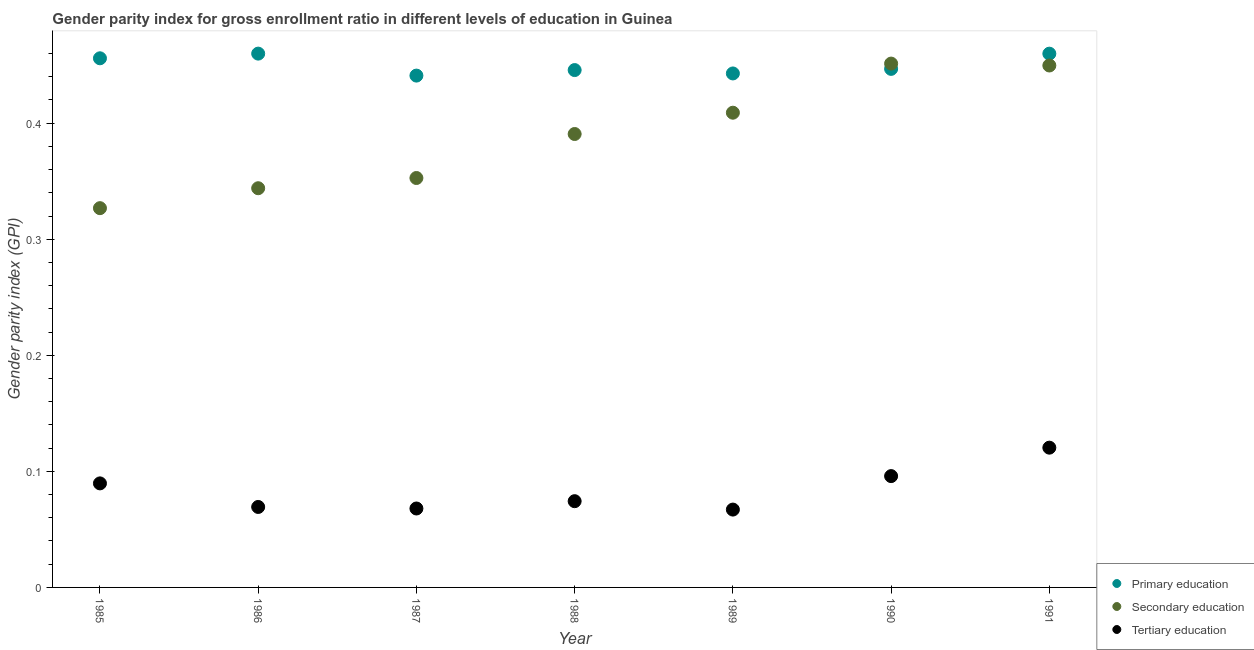How many different coloured dotlines are there?
Ensure brevity in your answer.  3. Is the number of dotlines equal to the number of legend labels?
Your answer should be compact. Yes. What is the gender parity index in tertiary education in 1991?
Your response must be concise. 0.12. Across all years, what is the maximum gender parity index in secondary education?
Your response must be concise. 0.45. Across all years, what is the minimum gender parity index in tertiary education?
Offer a very short reply. 0.07. In which year was the gender parity index in secondary education maximum?
Your response must be concise. 1990. In which year was the gender parity index in secondary education minimum?
Provide a short and direct response. 1985. What is the total gender parity index in secondary education in the graph?
Provide a succinct answer. 2.72. What is the difference between the gender parity index in primary education in 1986 and that in 1987?
Give a very brief answer. 0.02. What is the difference between the gender parity index in tertiary education in 1988 and the gender parity index in primary education in 1991?
Your answer should be compact. -0.39. What is the average gender parity index in secondary education per year?
Give a very brief answer. 0.39. In the year 1991, what is the difference between the gender parity index in secondary education and gender parity index in tertiary education?
Provide a short and direct response. 0.33. What is the ratio of the gender parity index in secondary education in 1985 to that in 1987?
Provide a succinct answer. 0.93. What is the difference between the highest and the second highest gender parity index in secondary education?
Your response must be concise. 0. What is the difference between the highest and the lowest gender parity index in secondary education?
Ensure brevity in your answer.  0.12. Is the sum of the gender parity index in secondary education in 1986 and 1987 greater than the maximum gender parity index in primary education across all years?
Your answer should be compact. Yes. Is it the case that in every year, the sum of the gender parity index in primary education and gender parity index in secondary education is greater than the gender parity index in tertiary education?
Provide a short and direct response. Yes. Does the gender parity index in tertiary education monotonically increase over the years?
Provide a succinct answer. No. Is the gender parity index in primary education strictly greater than the gender parity index in secondary education over the years?
Offer a terse response. No. How many dotlines are there?
Your response must be concise. 3. What is the title of the graph?
Your response must be concise. Gender parity index for gross enrollment ratio in different levels of education in Guinea. Does "Ores and metals" appear as one of the legend labels in the graph?
Keep it short and to the point. No. What is the label or title of the X-axis?
Ensure brevity in your answer.  Year. What is the label or title of the Y-axis?
Offer a very short reply. Gender parity index (GPI). What is the Gender parity index (GPI) in Primary education in 1985?
Give a very brief answer. 0.46. What is the Gender parity index (GPI) of Secondary education in 1985?
Your answer should be compact. 0.33. What is the Gender parity index (GPI) in Tertiary education in 1985?
Keep it short and to the point. 0.09. What is the Gender parity index (GPI) of Primary education in 1986?
Your answer should be compact. 0.46. What is the Gender parity index (GPI) of Secondary education in 1986?
Your answer should be very brief. 0.34. What is the Gender parity index (GPI) of Tertiary education in 1986?
Your answer should be compact. 0.07. What is the Gender parity index (GPI) of Primary education in 1987?
Offer a very short reply. 0.44. What is the Gender parity index (GPI) in Secondary education in 1987?
Offer a terse response. 0.35. What is the Gender parity index (GPI) in Tertiary education in 1987?
Provide a succinct answer. 0.07. What is the Gender parity index (GPI) of Primary education in 1988?
Your response must be concise. 0.45. What is the Gender parity index (GPI) in Secondary education in 1988?
Ensure brevity in your answer.  0.39. What is the Gender parity index (GPI) in Tertiary education in 1988?
Your answer should be very brief. 0.07. What is the Gender parity index (GPI) of Primary education in 1989?
Provide a short and direct response. 0.44. What is the Gender parity index (GPI) of Secondary education in 1989?
Ensure brevity in your answer.  0.41. What is the Gender parity index (GPI) of Tertiary education in 1989?
Ensure brevity in your answer.  0.07. What is the Gender parity index (GPI) of Primary education in 1990?
Your answer should be very brief. 0.45. What is the Gender parity index (GPI) of Secondary education in 1990?
Offer a very short reply. 0.45. What is the Gender parity index (GPI) of Tertiary education in 1990?
Provide a succinct answer. 0.1. What is the Gender parity index (GPI) in Primary education in 1991?
Offer a terse response. 0.46. What is the Gender parity index (GPI) of Secondary education in 1991?
Your response must be concise. 0.45. What is the Gender parity index (GPI) of Tertiary education in 1991?
Offer a very short reply. 0.12. Across all years, what is the maximum Gender parity index (GPI) in Primary education?
Provide a short and direct response. 0.46. Across all years, what is the maximum Gender parity index (GPI) of Secondary education?
Give a very brief answer. 0.45. Across all years, what is the maximum Gender parity index (GPI) in Tertiary education?
Provide a short and direct response. 0.12. Across all years, what is the minimum Gender parity index (GPI) in Primary education?
Offer a very short reply. 0.44. Across all years, what is the minimum Gender parity index (GPI) in Secondary education?
Your answer should be very brief. 0.33. Across all years, what is the minimum Gender parity index (GPI) in Tertiary education?
Give a very brief answer. 0.07. What is the total Gender parity index (GPI) of Primary education in the graph?
Ensure brevity in your answer.  3.15. What is the total Gender parity index (GPI) of Secondary education in the graph?
Offer a terse response. 2.72. What is the total Gender parity index (GPI) in Tertiary education in the graph?
Ensure brevity in your answer.  0.58. What is the difference between the Gender parity index (GPI) of Primary education in 1985 and that in 1986?
Your response must be concise. -0. What is the difference between the Gender parity index (GPI) of Secondary education in 1985 and that in 1986?
Provide a short and direct response. -0.02. What is the difference between the Gender parity index (GPI) of Tertiary education in 1985 and that in 1986?
Keep it short and to the point. 0.02. What is the difference between the Gender parity index (GPI) in Primary education in 1985 and that in 1987?
Offer a very short reply. 0.01. What is the difference between the Gender parity index (GPI) in Secondary education in 1985 and that in 1987?
Provide a short and direct response. -0.03. What is the difference between the Gender parity index (GPI) of Tertiary education in 1985 and that in 1987?
Offer a very short reply. 0.02. What is the difference between the Gender parity index (GPI) of Primary education in 1985 and that in 1988?
Keep it short and to the point. 0.01. What is the difference between the Gender parity index (GPI) of Secondary education in 1985 and that in 1988?
Give a very brief answer. -0.06. What is the difference between the Gender parity index (GPI) in Tertiary education in 1985 and that in 1988?
Provide a succinct answer. 0.02. What is the difference between the Gender parity index (GPI) of Primary education in 1985 and that in 1989?
Your answer should be compact. 0.01. What is the difference between the Gender parity index (GPI) of Secondary education in 1985 and that in 1989?
Keep it short and to the point. -0.08. What is the difference between the Gender parity index (GPI) of Tertiary education in 1985 and that in 1989?
Your answer should be compact. 0.02. What is the difference between the Gender parity index (GPI) in Primary education in 1985 and that in 1990?
Your answer should be compact. 0.01. What is the difference between the Gender parity index (GPI) of Secondary education in 1985 and that in 1990?
Your answer should be very brief. -0.12. What is the difference between the Gender parity index (GPI) in Tertiary education in 1985 and that in 1990?
Offer a very short reply. -0.01. What is the difference between the Gender parity index (GPI) in Primary education in 1985 and that in 1991?
Offer a very short reply. -0. What is the difference between the Gender parity index (GPI) of Secondary education in 1985 and that in 1991?
Your response must be concise. -0.12. What is the difference between the Gender parity index (GPI) of Tertiary education in 1985 and that in 1991?
Give a very brief answer. -0.03. What is the difference between the Gender parity index (GPI) of Primary education in 1986 and that in 1987?
Your response must be concise. 0.02. What is the difference between the Gender parity index (GPI) in Secondary education in 1986 and that in 1987?
Keep it short and to the point. -0.01. What is the difference between the Gender parity index (GPI) of Tertiary education in 1986 and that in 1987?
Your response must be concise. 0. What is the difference between the Gender parity index (GPI) of Primary education in 1986 and that in 1988?
Make the answer very short. 0.01. What is the difference between the Gender parity index (GPI) of Secondary education in 1986 and that in 1988?
Offer a terse response. -0.05. What is the difference between the Gender parity index (GPI) in Tertiary education in 1986 and that in 1988?
Keep it short and to the point. -0.01. What is the difference between the Gender parity index (GPI) of Primary education in 1986 and that in 1989?
Your answer should be compact. 0.02. What is the difference between the Gender parity index (GPI) in Secondary education in 1986 and that in 1989?
Offer a very short reply. -0.07. What is the difference between the Gender parity index (GPI) in Tertiary education in 1986 and that in 1989?
Give a very brief answer. 0. What is the difference between the Gender parity index (GPI) in Primary education in 1986 and that in 1990?
Give a very brief answer. 0.01. What is the difference between the Gender parity index (GPI) of Secondary education in 1986 and that in 1990?
Ensure brevity in your answer.  -0.11. What is the difference between the Gender parity index (GPI) of Tertiary education in 1986 and that in 1990?
Give a very brief answer. -0.03. What is the difference between the Gender parity index (GPI) in Primary education in 1986 and that in 1991?
Your answer should be compact. 0. What is the difference between the Gender parity index (GPI) in Secondary education in 1986 and that in 1991?
Offer a terse response. -0.11. What is the difference between the Gender parity index (GPI) in Tertiary education in 1986 and that in 1991?
Make the answer very short. -0.05. What is the difference between the Gender parity index (GPI) in Primary education in 1987 and that in 1988?
Offer a terse response. -0. What is the difference between the Gender parity index (GPI) of Secondary education in 1987 and that in 1988?
Provide a succinct answer. -0.04. What is the difference between the Gender parity index (GPI) in Tertiary education in 1987 and that in 1988?
Offer a very short reply. -0.01. What is the difference between the Gender parity index (GPI) of Primary education in 1987 and that in 1989?
Provide a short and direct response. -0. What is the difference between the Gender parity index (GPI) in Secondary education in 1987 and that in 1989?
Provide a succinct answer. -0.06. What is the difference between the Gender parity index (GPI) of Tertiary education in 1987 and that in 1989?
Your answer should be very brief. 0. What is the difference between the Gender parity index (GPI) of Primary education in 1987 and that in 1990?
Give a very brief answer. -0.01. What is the difference between the Gender parity index (GPI) of Secondary education in 1987 and that in 1990?
Make the answer very short. -0.1. What is the difference between the Gender parity index (GPI) in Tertiary education in 1987 and that in 1990?
Your answer should be compact. -0.03. What is the difference between the Gender parity index (GPI) in Primary education in 1987 and that in 1991?
Make the answer very short. -0.02. What is the difference between the Gender parity index (GPI) of Secondary education in 1987 and that in 1991?
Your answer should be very brief. -0.1. What is the difference between the Gender parity index (GPI) of Tertiary education in 1987 and that in 1991?
Keep it short and to the point. -0.05. What is the difference between the Gender parity index (GPI) of Primary education in 1988 and that in 1989?
Give a very brief answer. 0. What is the difference between the Gender parity index (GPI) in Secondary education in 1988 and that in 1989?
Make the answer very short. -0.02. What is the difference between the Gender parity index (GPI) in Tertiary education in 1988 and that in 1989?
Ensure brevity in your answer.  0.01. What is the difference between the Gender parity index (GPI) of Primary education in 1988 and that in 1990?
Offer a terse response. -0. What is the difference between the Gender parity index (GPI) in Secondary education in 1988 and that in 1990?
Offer a very short reply. -0.06. What is the difference between the Gender parity index (GPI) in Tertiary education in 1988 and that in 1990?
Give a very brief answer. -0.02. What is the difference between the Gender parity index (GPI) in Primary education in 1988 and that in 1991?
Your response must be concise. -0.01. What is the difference between the Gender parity index (GPI) of Secondary education in 1988 and that in 1991?
Provide a short and direct response. -0.06. What is the difference between the Gender parity index (GPI) in Tertiary education in 1988 and that in 1991?
Offer a very short reply. -0.05. What is the difference between the Gender parity index (GPI) in Primary education in 1989 and that in 1990?
Your answer should be compact. -0. What is the difference between the Gender parity index (GPI) of Secondary education in 1989 and that in 1990?
Ensure brevity in your answer.  -0.04. What is the difference between the Gender parity index (GPI) in Tertiary education in 1989 and that in 1990?
Ensure brevity in your answer.  -0.03. What is the difference between the Gender parity index (GPI) of Primary education in 1989 and that in 1991?
Keep it short and to the point. -0.02. What is the difference between the Gender parity index (GPI) of Secondary education in 1989 and that in 1991?
Offer a very short reply. -0.04. What is the difference between the Gender parity index (GPI) of Tertiary education in 1989 and that in 1991?
Keep it short and to the point. -0.05. What is the difference between the Gender parity index (GPI) in Primary education in 1990 and that in 1991?
Make the answer very short. -0.01. What is the difference between the Gender parity index (GPI) in Secondary education in 1990 and that in 1991?
Your answer should be very brief. 0. What is the difference between the Gender parity index (GPI) in Tertiary education in 1990 and that in 1991?
Ensure brevity in your answer.  -0.02. What is the difference between the Gender parity index (GPI) in Primary education in 1985 and the Gender parity index (GPI) in Secondary education in 1986?
Provide a succinct answer. 0.11. What is the difference between the Gender parity index (GPI) in Primary education in 1985 and the Gender parity index (GPI) in Tertiary education in 1986?
Your response must be concise. 0.39. What is the difference between the Gender parity index (GPI) of Secondary education in 1985 and the Gender parity index (GPI) of Tertiary education in 1986?
Provide a succinct answer. 0.26. What is the difference between the Gender parity index (GPI) in Primary education in 1985 and the Gender parity index (GPI) in Secondary education in 1987?
Provide a succinct answer. 0.1. What is the difference between the Gender parity index (GPI) of Primary education in 1985 and the Gender parity index (GPI) of Tertiary education in 1987?
Offer a terse response. 0.39. What is the difference between the Gender parity index (GPI) of Secondary education in 1985 and the Gender parity index (GPI) of Tertiary education in 1987?
Offer a very short reply. 0.26. What is the difference between the Gender parity index (GPI) of Primary education in 1985 and the Gender parity index (GPI) of Secondary education in 1988?
Provide a succinct answer. 0.07. What is the difference between the Gender parity index (GPI) in Primary education in 1985 and the Gender parity index (GPI) in Tertiary education in 1988?
Keep it short and to the point. 0.38. What is the difference between the Gender parity index (GPI) of Secondary education in 1985 and the Gender parity index (GPI) of Tertiary education in 1988?
Offer a very short reply. 0.25. What is the difference between the Gender parity index (GPI) in Primary education in 1985 and the Gender parity index (GPI) in Secondary education in 1989?
Provide a succinct answer. 0.05. What is the difference between the Gender parity index (GPI) of Primary education in 1985 and the Gender parity index (GPI) of Tertiary education in 1989?
Your response must be concise. 0.39. What is the difference between the Gender parity index (GPI) of Secondary education in 1985 and the Gender parity index (GPI) of Tertiary education in 1989?
Offer a very short reply. 0.26. What is the difference between the Gender parity index (GPI) of Primary education in 1985 and the Gender parity index (GPI) of Secondary education in 1990?
Offer a very short reply. 0. What is the difference between the Gender parity index (GPI) of Primary education in 1985 and the Gender parity index (GPI) of Tertiary education in 1990?
Offer a very short reply. 0.36. What is the difference between the Gender parity index (GPI) in Secondary education in 1985 and the Gender parity index (GPI) in Tertiary education in 1990?
Your answer should be very brief. 0.23. What is the difference between the Gender parity index (GPI) in Primary education in 1985 and the Gender parity index (GPI) in Secondary education in 1991?
Your response must be concise. 0.01. What is the difference between the Gender parity index (GPI) of Primary education in 1985 and the Gender parity index (GPI) of Tertiary education in 1991?
Make the answer very short. 0.34. What is the difference between the Gender parity index (GPI) of Secondary education in 1985 and the Gender parity index (GPI) of Tertiary education in 1991?
Provide a succinct answer. 0.21. What is the difference between the Gender parity index (GPI) in Primary education in 1986 and the Gender parity index (GPI) in Secondary education in 1987?
Offer a very short reply. 0.11. What is the difference between the Gender parity index (GPI) in Primary education in 1986 and the Gender parity index (GPI) in Tertiary education in 1987?
Offer a very short reply. 0.39. What is the difference between the Gender parity index (GPI) in Secondary education in 1986 and the Gender parity index (GPI) in Tertiary education in 1987?
Your answer should be very brief. 0.28. What is the difference between the Gender parity index (GPI) in Primary education in 1986 and the Gender parity index (GPI) in Secondary education in 1988?
Your answer should be very brief. 0.07. What is the difference between the Gender parity index (GPI) in Primary education in 1986 and the Gender parity index (GPI) in Tertiary education in 1988?
Provide a succinct answer. 0.39. What is the difference between the Gender parity index (GPI) of Secondary education in 1986 and the Gender parity index (GPI) of Tertiary education in 1988?
Keep it short and to the point. 0.27. What is the difference between the Gender parity index (GPI) of Primary education in 1986 and the Gender parity index (GPI) of Secondary education in 1989?
Offer a very short reply. 0.05. What is the difference between the Gender parity index (GPI) of Primary education in 1986 and the Gender parity index (GPI) of Tertiary education in 1989?
Your response must be concise. 0.39. What is the difference between the Gender parity index (GPI) in Secondary education in 1986 and the Gender parity index (GPI) in Tertiary education in 1989?
Make the answer very short. 0.28. What is the difference between the Gender parity index (GPI) in Primary education in 1986 and the Gender parity index (GPI) in Secondary education in 1990?
Offer a terse response. 0.01. What is the difference between the Gender parity index (GPI) in Primary education in 1986 and the Gender parity index (GPI) in Tertiary education in 1990?
Offer a terse response. 0.36. What is the difference between the Gender parity index (GPI) of Secondary education in 1986 and the Gender parity index (GPI) of Tertiary education in 1990?
Ensure brevity in your answer.  0.25. What is the difference between the Gender parity index (GPI) in Primary education in 1986 and the Gender parity index (GPI) in Secondary education in 1991?
Make the answer very short. 0.01. What is the difference between the Gender parity index (GPI) in Primary education in 1986 and the Gender parity index (GPI) in Tertiary education in 1991?
Your answer should be very brief. 0.34. What is the difference between the Gender parity index (GPI) in Secondary education in 1986 and the Gender parity index (GPI) in Tertiary education in 1991?
Keep it short and to the point. 0.22. What is the difference between the Gender parity index (GPI) of Primary education in 1987 and the Gender parity index (GPI) of Secondary education in 1988?
Your answer should be compact. 0.05. What is the difference between the Gender parity index (GPI) in Primary education in 1987 and the Gender parity index (GPI) in Tertiary education in 1988?
Your answer should be compact. 0.37. What is the difference between the Gender parity index (GPI) of Secondary education in 1987 and the Gender parity index (GPI) of Tertiary education in 1988?
Make the answer very short. 0.28. What is the difference between the Gender parity index (GPI) in Primary education in 1987 and the Gender parity index (GPI) in Secondary education in 1989?
Make the answer very short. 0.03. What is the difference between the Gender parity index (GPI) in Primary education in 1987 and the Gender parity index (GPI) in Tertiary education in 1989?
Keep it short and to the point. 0.37. What is the difference between the Gender parity index (GPI) of Secondary education in 1987 and the Gender parity index (GPI) of Tertiary education in 1989?
Your answer should be very brief. 0.29. What is the difference between the Gender parity index (GPI) of Primary education in 1987 and the Gender parity index (GPI) of Secondary education in 1990?
Offer a very short reply. -0.01. What is the difference between the Gender parity index (GPI) of Primary education in 1987 and the Gender parity index (GPI) of Tertiary education in 1990?
Provide a succinct answer. 0.35. What is the difference between the Gender parity index (GPI) in Secondary education in 1987 and the Gender parity index (GPI) in Tertiary education in 1990?
Provide a short and direct response. 0.26. What is the difference between the Gender parity index (GPI) of Primary education in 1987 and the Gender parity index (GPI) of Secondary education in 1991?
Provide a succinct answer. -0.01. What is the difference between the Gender parity index (GPI) in Primary education in 1987 and the Gender parity index (GPI) in Tertiary education in 1991?
Your answer should be compact. 0.32. What is the difference between the Gender parity index (GPI) in Secondary education in 1987 and the Gender parity index (GPI) in Tertiary education in 1991?
Give a very brief answer. 0.23. What is the difference between the Gender parity index (GPI) of Primary education in 1988 and the Gender parity index (GPI) of Secondary education in 1989?
Make the answer very short. 0.04. What is the difference between the Gender parity index (GPI) in Primary education in 1988 and the Gender parity index (GPI) in Tertiary education in 1989?
Your answer should be very brief. 0.38. What is the difference between the Gender parity index (GPI) in Secondary education in 1988 and the Gender parity index (GPI) in Tertiary education in 1989?
Make the answer very short. 0.32. What is the difference between the Gender parity index (GPI) of Primary education in 1988 and the Gender parity index (GPI) of Secondary education in 1990?
Your answer should be very brief. -0.01. What is the difference between the Gender parity index (GPI) of Primary education in 1988 and the Gender parity index (GPI) of Tertiary education in 1990?
Provide a succinct answer. 0.35. What is the difference between the Gender parity index (GPI) in Secondary education in 1988 and the Gender parity index (GPI) in Tertiary education in 1990?
Provide a succinct answer. 0.29. What is the difference between the Gender parity index (GPI) in Primary education in 1988 and the Gender parity index (GPI) in Secondary education in 1991?
Your response must be concise. -0. What is the difference between the Gender parity index (GPI) of Primary education in 1988 and the Gender parity index (GPI) of Tertiary education in 1991?
Make the answer very short. 0.33. What is the difference between the Gender parity index (GPI) in Secondary education in 1988 and the Gender parity index (GPI) in Tertiary education in 1991?
Your answer should be compact. 0.27. What is the difference between the Gender parity index (GPI) of Primary education in 1989 and the Gender parity index (GPI) of Secondary education in 1990?
Offer a terse response. -0.01. What is the difference between the Gender parity index (GPI) of Primary education in 1989 and the Gender parity index (GPI) of Tertiary education in 1990?
Provide a short and direct response. 0.35. What is the difference between the Gender parity index (GPI) in Secondary education in 1989 and the Gender parity index (GPI) in Tertiary education in 1990?
Keep it short and to the point. 0.31. What is the difference between the Gender parity index (GPI) of Primary education in 1989 and the Gender parity index (GPI) of Secondary education in 1991?
Offer a terse response. -0.01. What is the difference between the Gender parity index (GPI) in Primary education in 1989 and the Gender parity index (GPI) in Tertiary education in 1991?
Offer a very short reply. 0.32. What is the difference between the Gender parity index (GPI) of Secondary education in 1989 and the Gender parity index (GPI) of Tertiary education in 1991?
Give a very brief answer. 0.29. What is the difference between the Gender parity index (GPI) of Primary education in 1990 and the Gender parity index (GPI) of Secondary education in 1991?
Offer a very short reply. -0. What is the difference between the Gender parity index (GPI) in Primary education in 1990 and the Gender parity index (GPI) in Tertiary education in 1991?
Your answer should be compact. 0.33. What is the difference between the Gender parity index (GPI) of Secondary education in 1990 and the Gender parity index (GPI) of Tertiary education in 1991?
Make the answer very short. 0.33. What is the average Gender parity index (GPI) in Primary education per year?
Make the answer very short. 0.45. What is the average Gender parity index (GPI) of Secondary education per year?
Your answer should be very brief. 0.39. What is the average Gender parity index (GPI) in Tertiary education per year?
Offer a terse response. 0.08. In the year 1985, what is the difference between the Gender parity index (GPI) in Primary education and Gender parity index (GPI) in Secondary education?
Provide a succinct answer. 0.13. In the year 1985, what is the difference between the Gender parity index (GPI) in Primary education and Gender parity index (GPI) in Tertiary education?
Keep it short and to the point. 0.37. In the year 1985, what is the difference between the Gender parity index (GPI) of Secondary education and Gender parity index (GPI) of Tertiary education?
Provide a succinct answer. 0.24. In the year 1986, what is the difference between the Gender parity index (GPI) of Primary education and Gender parity index (GPI) of Secondary education?
Make the answer very short. 0.12. In the year 1986, what is the difference between the Gender parity index (GPI) in Primary education and Gender parity index (GPI) in Tertiary education?
Offer a very short reply. 0.39. In the year 1986, what is the difference between the Gender parity index (GPI) of Secondary education and Gender parity index (GPI) of Tertiary education?
Keep it short and to the point. 0.27. In the year 1987, what is the difference between the Gender parity index (GPI) of Primary education and Gender parity index (GPI) of Secondary education?
Your response must be concise. 0.09. In the year 1987, what is the difference between the Gender parity index (GPI) of Primary education and Gender parity index (GPI) of Tertiary education?
Keep it short and to the point. 0.37. In the year 1987, what is the difference between the Gender parity index (GPI) of Secondary education and Gender parity index (GPI) of Tertiary education?
Your answer should be compact. 0.28. In the year 1988, what is the difference between the Gender parity index (GPI) of Primary education and Gender parity index (GPI) of Secondary education?
Provide a short and direct response. 0.06. In the year 1988, what is the difference between the Gender parity index (GPI) of Primary education and Gender parity index (GPI) of Tertiary education?
Your response must be concise. 0.37. In the year 1988, what is the difference between the Gender parity index (GPI) in Secondary education and Gender parity index (GPI) in Tertiary education?
Keep it short and to the point. 0.32. In the year 1989, what is the difference between the Gender parity index (GPI) in Primary education and Gender parity index (GPI) in Secondary education?
Make the answer very short. 0.03. In the year 1989, what is the difference between the Gender parity index (GPI) in Primary education and Gender parity index (GPI) in Tertiary education?
Ensure brevity in your answer.  0.38. In the year 1989, what is the difference between the Gender parity index (GPI) of Secondary education and Gender parity index (GPI) of Tertiary education?
Give a very brief answer. 0.34. In the year 1990, what is the difference between the Gender parity index (GPI) of Primary education and Gender parity index (GPI) of Secondary education?
Give a very brief answer. -0. In the year 1990, what is the difference between the Gender parity index (GPI) in Primary education and Gender parity index (GPI) in Tertiary education?
Provide a succinct answer. 0.35. In the year 1990, what is the difference between the Gender parity index (GPI) of Secondary education and Gender parity index (GPI) of Tertiary education?
Your answer should be very brief. 0.36. In the year 1991, what is the difference between the Gender parity index (GPI) in Primary education and Gender parity index (GPI) in Secondary education?
Provide a short and direct response. 0.01. In the year 1991, what is the difference between the Gender parity index (GPI) in Primary education and Gender parity index (GPI) in Tertiary education?
Offer a very short reply. 0.34. In the year 1991, what is the difference between the Gender parity index (GPI) of Secondary education and Gender parity index (GPI) of Tertiary education?
Make the answer very short. 0.33. What is the ratio of the Gender parity index (GPI) in Primary education in 1985 to that in 1986?
Your answer should be compact. 0.99. What is the ratio of the Gender parity index (GPI) of Secondary education in 1985 to that in 1986?
Your answer should be very brief. 0.95. What is the ratio of the Gender parity index (GPI) of Tertiary education in 1985 to that in 1986?
Your answer should be compact. 1.29. What is the ratio of the Gender parity index (GPI) in Primary education in 1985 to that in 1987?
Ensure brevity in your answer.  1.03. What is the ratio of the Gender parity index (GPI) in Secondary education in 1985 to that in 1987?
Give a very brief answer. 0.93. What is the ratio of the Gender parity index (GPI) of Tertiary education in 1985 to that in 1987?
Ensure brevity in your answer.  1.32. What is the ratio of the Gender parity index (GPI) in Primary education in 1985 to that in 1988?
Keep it short and to the point. 1.02. What is the ratio of the Gender parity index (GPI) of Secondary education in 1985 to that in 1988?
Provide a succinct answer. 0.84. What is the ratio of the Gender parity index (GPI) of Tertiary education in 1985 to that in 1988?
Offer a very short reply. 1.21. What is the ratio of the Gender parity index (GPI) in Primary education in 1985 to that in 1989?
Your response must be concise. 1.03. What is the ratio of the Gender parity index (GPI) of Secondary education in 1985 to that in 1989?
Provide a succinct answer. 0.8. What is the ratio of the Gender parity index (GPI) of Tertiary education in 1985 to that in 1989?
Provide a short and direct response. 1.34. What is the ratio of the Gender parity index (GPI) in Primary education in 1985 to that in 1990?
Your answer should be compact. 1.02. What is the ratio of the Gender parity index (GPI) of Secondary education in 1985 to that in 1990?
Provide a succinct answer. 0.72. What is the ratio of the Gender parity index (GPI) in Tertiary education in 1985 to that in 1990?
Provide a succinct answer. 0.93. What is the ratio of the Gender parity index (GPI) of Primary education in 1985 to that in 1991?
Your answer should be very brief. 0.99. What is the ratio of the Gender parity index (GPI) in Secondary education in 1985 to that in 1991?
Keep it short and to the point. 0.73. What is the ratio of the Gender parity index (GPI) in Tertiary education in 1985 to that in 1991?
Your response must be concise. 0.74. What is the ratio of the Gender parity index (GPI) of Primary education in 1986 to that in 1987?
Provide a succinct answer. 1.04. What is the ratio of the Gender parity index (GPI) in Tertiary education in 1986 to that in 1987?
Offer a very short reply. 1.02. What is the ratio of the Gender parity index (GPI) in Primary education in 1986 to that in 1988?
Provide a succinct answer. 1.03. What is the ratio of the Gender parity index (GPI) of Secondary education in 1986 to that in 1988?
Your answer should be compact. 0.88. What is the ratio of the Gender parity index (GPI) of Tertiary education in 1986 to that in 1988?
Your answer should be very brief. 0.93. What is the ratio of the Gender parity index (GPI) of Primary education in 1986 to that in 1989?
Give a very brief answer. 1.04. What is the ratio of the Gender parity index (GPI) in Secondary education in 1986 to that in 1989?
Ensure brevity in your answer.  0.84. What is the ratio of the Gender parity index (GPI) in Tertiary education in 1986 to that in 1989?
Make the answer very short. 1.03. What is the ratio of the Gender parity index (GPI) in Primary education in 1986 to that in 1990?
Offer a terse response. 1.03. What is the ratio of the Gender parity index (GPI) of Secondary education in 1986 to that in 1990?
Give a very brief answer. 0.76. What is the ratio of the Gender parity index (GPI) of Tertiary education in 1986 to that in 1990?
Provide a succinct answer. 0.72. What is the ratio of the Gender parity index (GPI) of Primary education in 1986 to that in 1991?
Keep it short and to the point. 1. What is the ratio of the Gender parity index (GPI) of Secondary education in 1986 to that in 1991?
Offer a terse response. 0.76. What is the ratio of the Gender parity index (GPI) of Tertiary education in 1986 to that in 1991?
Keep it short and to the point. 0.58. What is the ratio of the Gender parity index (GPI) in Primary education in 1987 to that in 1988?
Make the answer very short. 0.99. What is the ratio of the Gender parity index (GPI) of Secondary education in 1987 to that in 1988?
Offer a terse response. 0.9. What is the ratio of the Gender parity index (GPI) in Tertiary education in 1987 to that in 1988?
Ensure brevity in your answer.  0.92. What is the ratio of the Gender parity index (GPI) of Secondary education in 1987 to that in 1989?
Make the answer very short. 0.86. What is the ratio of the Gender parity index (GPI) of Tertiary education in 1987 to that in 1989?
Your answer should be compact. 1.01. What is the ratio of the Gender parity index (GPI) of Primary education in 1987 to that in 1990?
Your response must be concise. 0.99. What is the ratio of the Gender parity index (GPI) in Secondary education in 1987 to that in 1990?
Your response must be concise. 0.78. What is the ratio of the Gender parity index (GPI) in Tertiary education in 1987 to that in 1990?
Your answer should be very brief. 0.71. What is the ratio of the Gender parity index (GPI) of Primary education in 1987 to that in 1991?
Your answer should be compact. 0.96. What is the ratio of the Gender parity index (GPI) in Secondary education in 1987 to that in 1991?
Ensure brevity in your answer.  0.78. What is the ratio of the Gender parity index (GPI) of Tertiary education in 1987 to that in 1991?
Keep it short and to the point. 0.56. What is the ratio of the Gender parity index (GPI) in Primary education in 1988 to that in 1989?
Provide a succinct answer. 1.01. What is the ratio of the Gender parity index (GPI) in Secondary education in 1988 to that in 1989?
Your answer should be very brief. 0.96. What is the ratio of the Gender parity index (GPI) of Tertiary education in 1988 to that in 1989?
Provide a short and direct response. 1.11. What is the ratio of the Gender parity index (GPI) of Primary education in 1988 to that in 1990?
Your response must be concise. 1. What is the ratio of the Gender parity index (GPI) of Secondary education in 1988 to that in 1990?
Your response must be concise. 0.87. What is the ratio of the Gender parity index (GPI) of Tertiary education in 1988 to that in 1990?
Your answer should be compact. 0.77. What is the ratio of the Gender parity index (GPI) of Primary education in 1988 to that in 1991?
Offer a terse response. 0.97. What is the ratio of the Gender parity index (GPI) in Secondary education in 1988 to that in 1991?
Offer a very short reply. 0.87. What is the ratio of the Gender parity index (GPI) of Tertiary education in 1988 to that in 1991?
Provide a short and direct response. 0.62. What is the ratio of the Gender parity index (GPI) of Primary education in 1989 to that in 1990?
Offer a very short reply. 0.99. What is the ratio of the Gender parity index (GPI) of Secondary education in 1989 to that in 1990?
Give a very brief answer. 0.91. What is the ratio of the Gender parity index (GPI) in Tertiary education in 1989 to that in 1990?
Your response must be concise. 0.7. What is the ratio of the Gender parity index (GPI) in Primary education in 1989 to that in 1991?
Offer a very short reply. 0.96. What is the ratio of the Gender parity index (GPI) of Secondary education in 1989 to that in 1991?
Your answer should be very brief. 0.91. What is the ratio of the Gender parity index (GPI) of Tertiary education in 1989 to that in 1991?
Provide a succinct answer. 0.56. What is the ratio of the Gender parity index (GPI) in Primary education in 1990 to that in 1991?
Your answer should be very brief. 0.97. What is the ratio of the Gender parity index (GPI) in Secondary education in 1990 to that in 1991?
Your answer should be very brief. 1. What is the ratio of the Gender parity index (GPI) of Tertiary education in 1990 to that in 1991?
Your answer should be very brief. 0.8. What is the difference between the highest and the second highest Gender parity index (GPI) of Primary education?
Keep it short and to the point. 0. What is the difference between the highest and the second highest Gender parity index (GPI) of Secondary education?
Offer a terse response. 0. What is the difference between the highest and the second highest Gender parity index (GPI) in Tertiary education?
Make the answer very short. 0.02. What is the difference between the highest and the lowest Gender parity index (GPI) in Primary education?
Provide a succinct answer. 0.02. What is the difference between the highest and the lowest Gender parity index (GPI) in Secondary education?
Provide a short and direct response. 0.12. What is the difference between the highest and the lowest Gender parity index (GPI) in Tertiary education?
Keep it short and to the point. 0.05. 